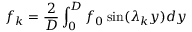Convert formula to latex. <formula><loc_0><loc_0><loc_500><loc_500>f _ { k } = \frac { 2 } { D } \int _ { 0 } ^ { D } f _ { 0 } \sin ( \lambda _ { k } y ) d y</formula> 